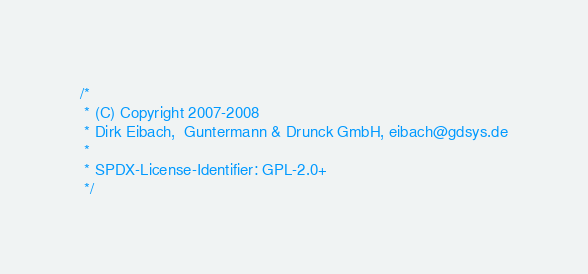Convert code to text. <code><loc_0><loc_0><loc_500><loc_500><_C_>/*
 * (C) Copyright 2007-2008
 * Dirk Eibach,  Guntermann & Drunck GmbH, eibach@gdsys.de
 *
 * SPDX-License-Identifier:	GPL-2.0+
 */
</code> 